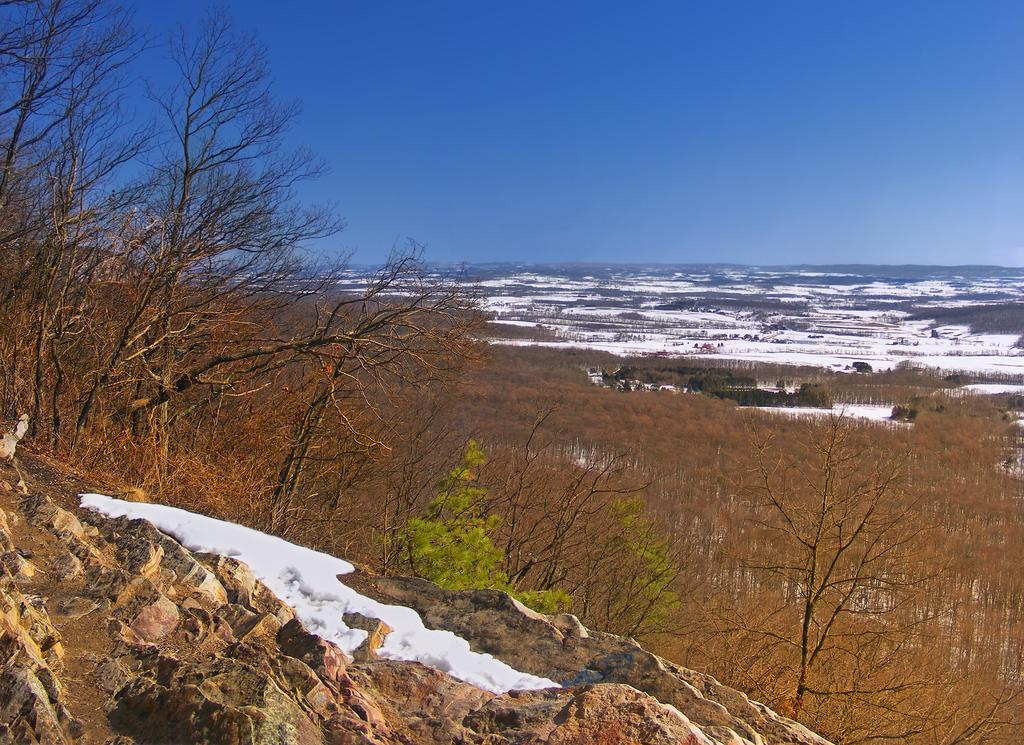What is the main subject of the image? There is a rock in the image. What can be seen in the background of the image? There are trees and the sky visible in the background of the image. What is the condition of the surface at the bottom of the image? There is snow on the surface at the bottom of the image. How many cats are sitting on the rock in the image? There are no cats present in the image; it features a rock with snow on the surface. What type of pickle is visible on the rock in the image? There is no pickle present in the image; it features a rock with snow on the surface. 